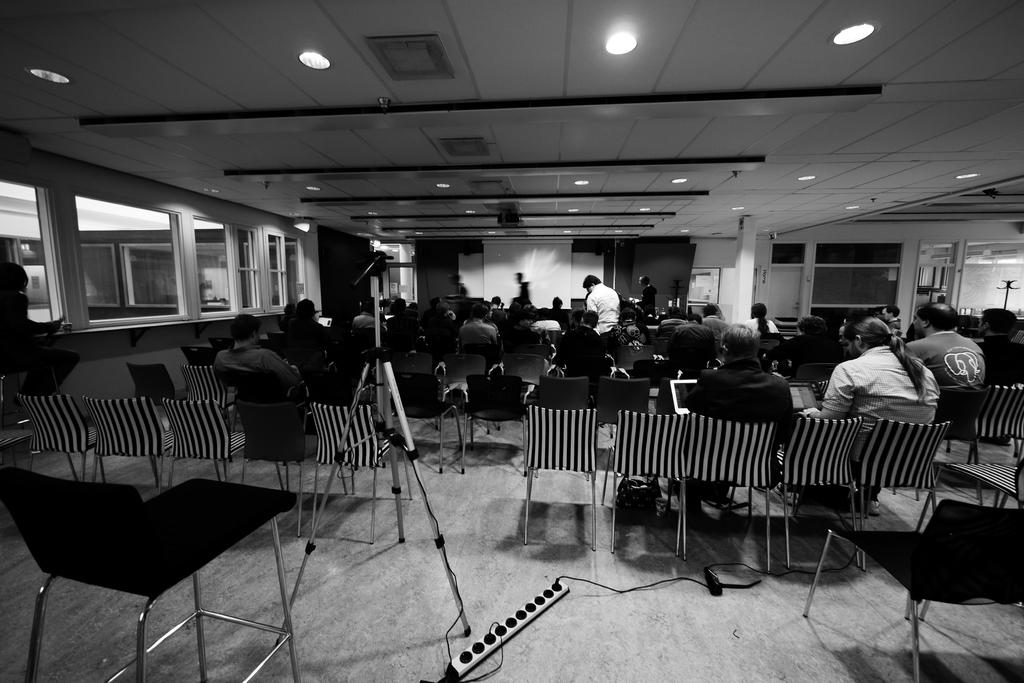What type of furniture is present in the image? There are chairs in the image. What are the people on the chairs doing? There are people sitting on the chairs. What can be seen in the background of the image? There is a projector's screen in the background of the image. What type of pies are being served on the swing in the image? There is no swing or pies present in the image. What is the earth's position in relation to the chairs in the image? The earth's position is not relevant to the image, as it is not depicted. 